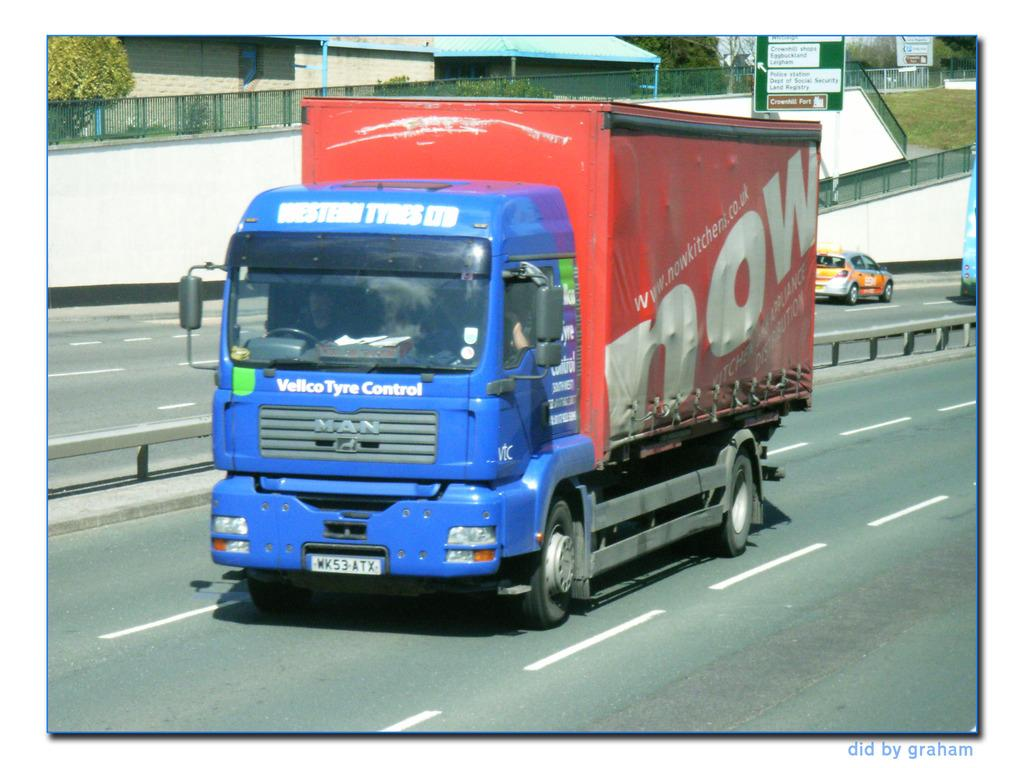What can be seen on the road in the image? There are vehicles on the road in the image. What is visible in the background of the image? There is a board, railing, houses, and many trees in the background of the image. Can you see a donkey smashing a needle with its hoof in the image? No, there is no donkey or needle present in the image. 